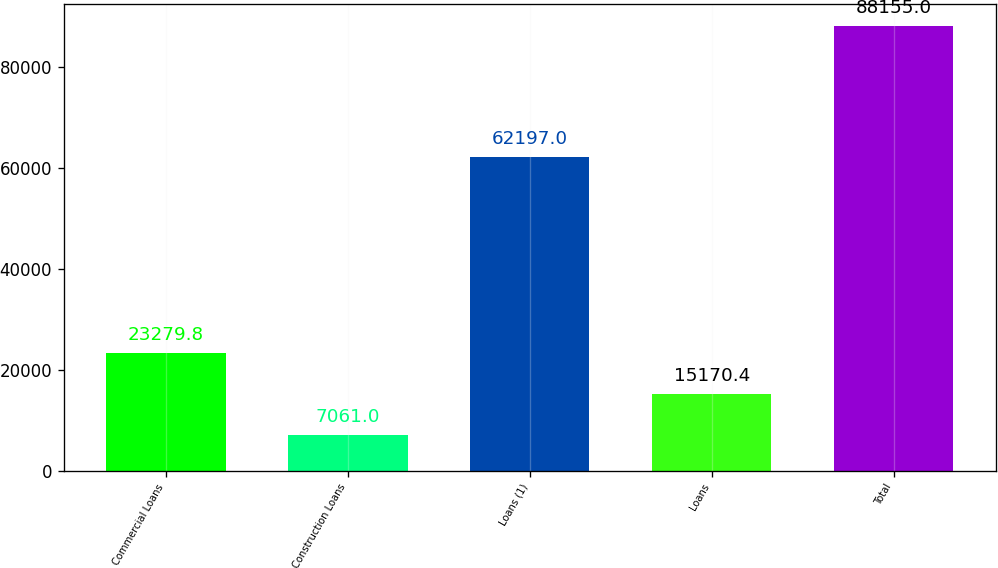Convert chart. <chart><loc_0><loc_0><loc_500><loc_500><bar_chart><fcel>Commercial Loans<fcel>Construction Loans<fcel>Loans (1)<fcel>Loans<fcel>Total<nl><fcel>23279.8<fcel>7061<fcel>62197<fcel>15170.4<fcel>88155<nl></chart> 